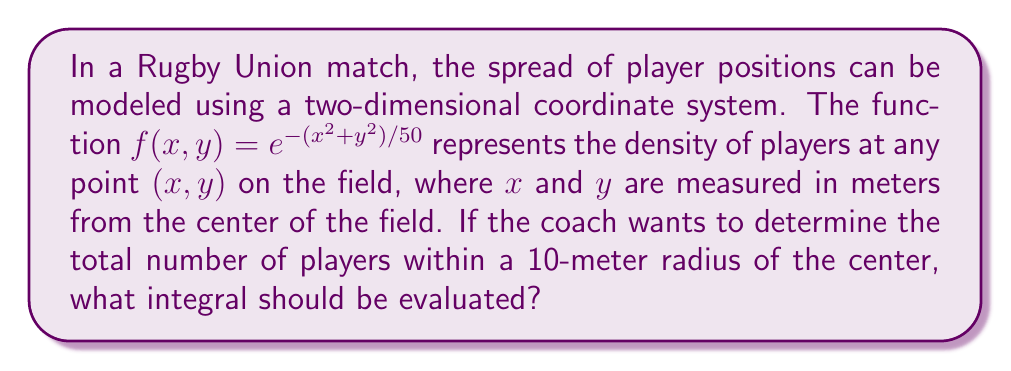Show me your answer to this math problem. To solve this problem, we need to follow these steps:

1) The density function is given by $f(x,y) = e^{-(x^2+y^2)/50}$.

2) We need to integrate this function over a circular region with a radius of 10 meters.

3) Given the circular symmetry of the problem, it's best to use polar coordinates. The transformation is:
   $x = r\cos(\theta)$
   $y = r\sin(\theta)$

4) In polar coordinates, the function becomes:
   $f(r,\theta) = e^{-r^2/50}$

5) The area element in polar coordinates is $r\,dr\,d\theta$.

6) The limits of integration will be:
   $0 \leq r \leq 10$ (radius from 0 to 10 meters)
   $0 \leq \theta \leq 2\pi$ (full circle)

7) Therefore, the integral to evaluate is:

   $$\int_0^{2\pi} \int_0^{10} e^{-r^2/50} r \,dr \,d\theta$$

This double integral represents the total number of players within a 10-meter radius of the center of the field.
Answer: $$\int_0^{2\pi} \int_0^{10} e^{-r^2/50} r \,dr \,d\theta$$ 